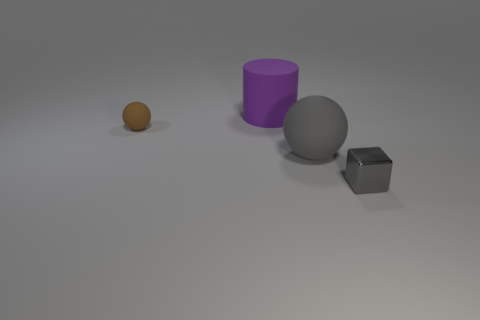There is a object that is both behind the metallic cube and on the right side of the purple rubber thing; what is its shape?
Keep it short and to the point. Sphere. How many things are brown matte spheres to the left of the tiny gray object or gray things that are on the left side of the gray cube?
Offer a very short reply. 2. Are there the same number of brown objects that are on the right side of the small shiny cube and gray cubes behind the large cylinder?
Give a very brief answer. Yes. The big thing in front of the tiny thing that is left of the purple object is what shape?
Provide a succinct answer. Sphere. Is there a big brown shiny thing of the same shape as the gray matte thing?
Your response must be concise. No. What number of small things are there?
Your answer should be very brief. 2. Is the large thing behind the small sphere made of the same material as the tiny sphere?
Give a very brief answer. Yes. Is there a purple object of the same size as the gray matte ball?
Offer a very short reply. Yes. There is a gray rubber object; is its shape the same as the object behind the tiny brown matte object?
Your answer should be compact. No. There is a rubber ball to the left of the gray thing that is on the left side of the small metal thing; are there any tiny gray cubes on the left side of it?
Your response must be concise. No. 